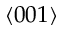Convert formula to latex. <formula><loc_0><loc_0><loc_500><loc_500>\langle 0 0 1 \rangle</formula> 